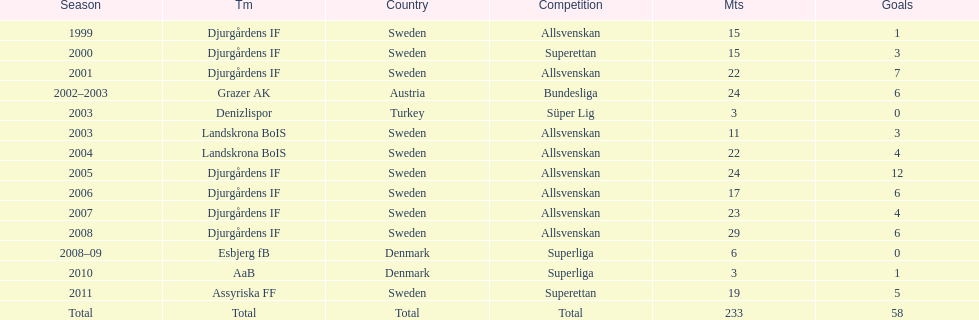What season has the most goals? 2005. 